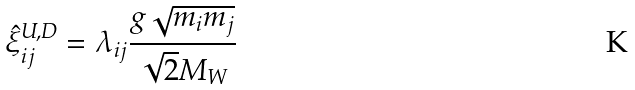<formula> <loc_0><loc_0><loc_500><loc_500>\hat { \xi } ^ { U , D } _ { i j } = \lambda _ { i j } \frac { g \sqrt { m _ { i } m _ { j } } } { \sqrt { 2 } M _ { W } }</formula> 